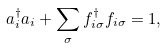<formula> <loc_0><loc_0><loc_500><loc_500>a ^ { \dagger } _ { i } a _ { i } + \sum _ { \sigma } f ^ { \dagger } _ { i \sigma } f _ { i \sigma } = 1 ,</formula> 